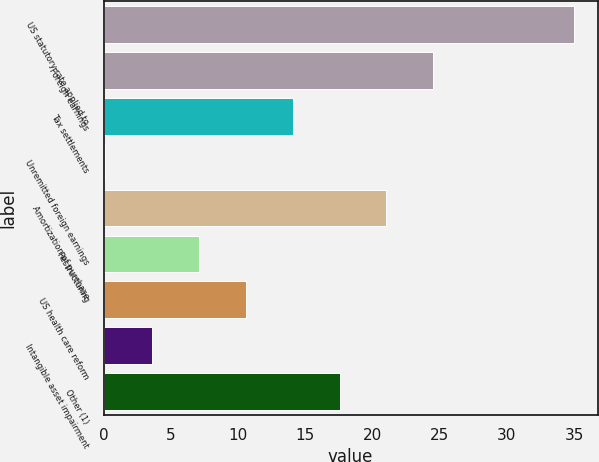<chart> <loc_0><loc_0><loc_500><loc_500><bar_chart><fcel>US statutory rate applied to<fcel>Foreign earnings<fcel>Tax settlements<fcel>Unremitted foreign earnings<fcel>Amortization of purchase<fcel>Restructuring<fcel>US health care reform<fcel>Intangible asset impairment<fcel>Other (1)<nl><fcel>35<fcel>24.53<fcel>14.06<fcel>0.1<fcel>21.04<fcel>7.08<fcel>10.57<fcel>3.59<fcel>17.55<nl></chart> 